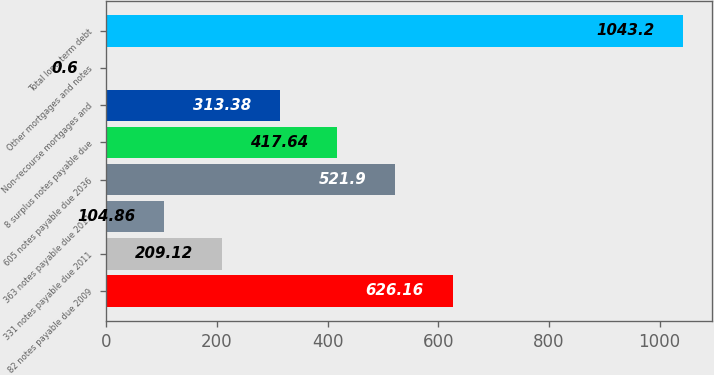Convert chart to OTSL. <chart><loc_0><loc_0><loc_500><loc_500><bar_chart><fcel>82 notes payable due 2009<fcel>331 notes payable due 2011<fcel>363 notes payable due 2011<fcel>605 notes payable due 2036<fcel>8 surplus notes payable due<fcel>Non-recourse mortgages and<fcel>Other mortgages and notes<fcel>Total long-term debt<nl><fcel>626.16<fcel>209.12<fcel>104.86<fcel>521.9<fcel>417.64<fcel>313.38<fcel>0.6<fcel>1043.2<nl></chart> 